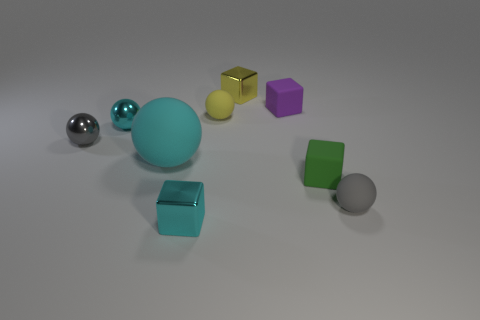Subtract all purple cubes. How many cubes are left? 3 Subtract all gray balls. How many balls are left? 3 Add 1 tiny green metallic balls. How many objects exist? 10 Subtract all yellow cylinders. How many gray spheres are left? 2 Subtract all cubes. How many objects are left? 5 Subtract 0 cyan cylinders. How many objects are left? 9 Subtract 1 blocks. How many blocks are left? 3 Subtract all purple blocks. Subtract all cyan balls. How many blocks are left? 3 Subtract all big cyan spheres. Subtract all rubber cubes. How many objects are left? 6 Add 5 yellow rubber spheres. How many yellow rubber spheres are left? 6 